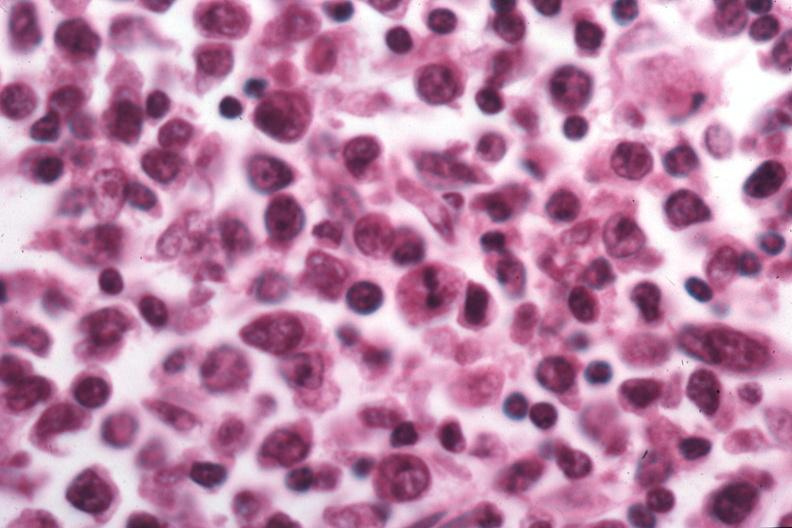s malignant lymphoma present?
Answer the question using a single word or phrase. Yes 